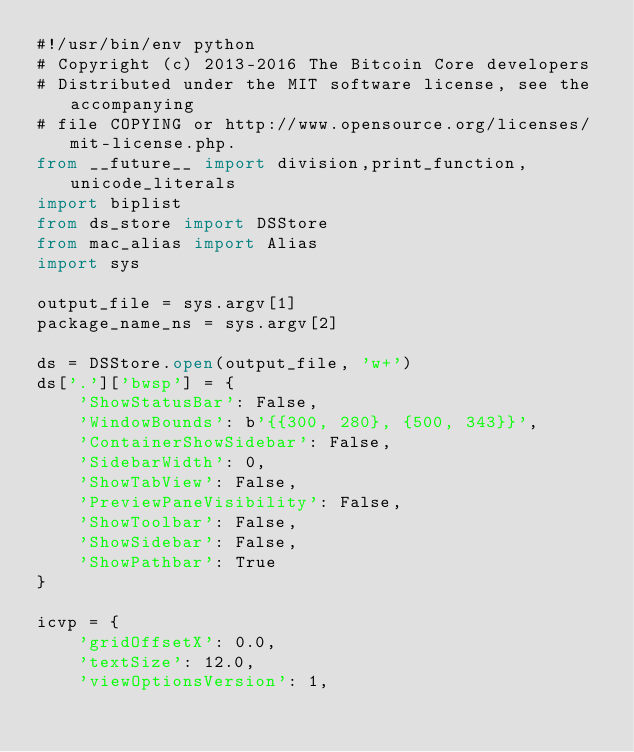Convert code to text. <code><loc_0><loc_0><loc_500><loc_500><_Python_>#!/usr/bin/env python
# Copyright (c) 2013-2016 The Bitcoin Core developers
# Distributed under the MIT software license, see the accompanying
# file COPYING or http://www.opensource.org/licenses/mit-license.php.
from __future__ import division,print_function,unicode_literals
import biplist
from ds_store import DSStore
from mac_alias import Alias
import sys

output_file = sys.argv[1]
package_name_ns = sys.argv[2]

ds = DSStore.open(output_file, 'w+')
ds['.']['bwsp'] = {
    'ShowStatusBar': False,
    'WindowBounds': b'{{300, 280}, {500, 343}}',
    'ContainerShowSidebar': False,
    'SidebarWidth': 0,
    'ShowTabView': False,
    'PreviewPaneVisibility': False,
    'ShowToolbar': False,
    'ShowSidebar': False,
    'ShowPathbar': True
}

icvp = {
    'gridOffsetX': 0.0,
    'textSize': 12.0,
    'viewOptionsVersion': 1,</code> 